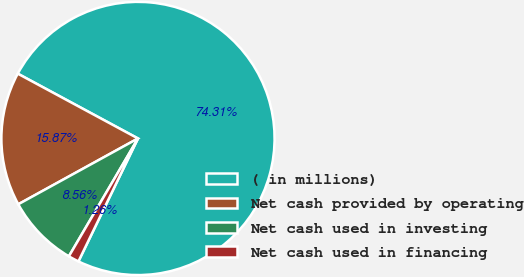Convert chart. <chart><loc_0><loc_0><loc_500><loc_500><pie_chart><fcel>( in millions)<fcel>Net cash provided by operating<fcel>Net cash used in investing<fcel>Net cash used in financing<nl><fcel>74.31%<fcel>15.87%<fcel>8.56%<fcel>1.26%<nl></chart> 